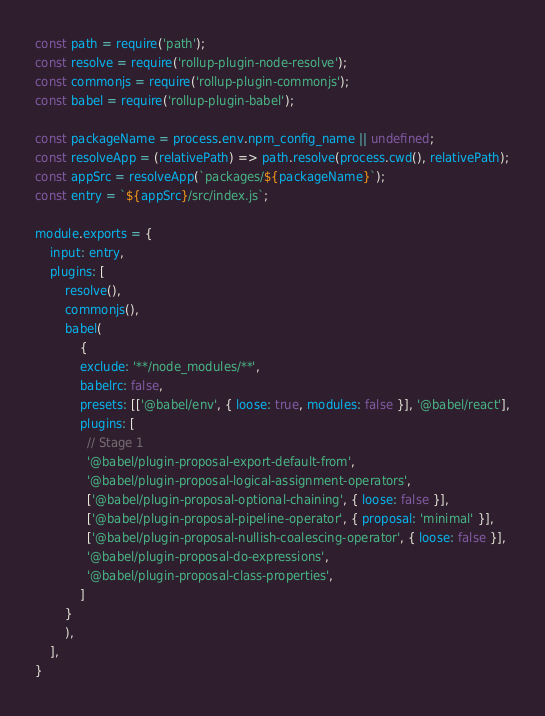Convert code to text. <code><loc_0><loc_0><loc_500><loc_500><_JavaScript_>const path = require('path');
const resolve = require('rollup-plugin-node-resolve');
const commonjs = require('rollup-plugin-commonjs');
const babel = require('rollup-plugin-babel');

const packageName = process.env.npm_config_name || undefined;
const resolveApp = (relativePath) => path.resolve(process.cwd(), relativePath);
const appSrc = resolveApp(`packages/${packageName}`);
const entry = `${appSrc}/src/index.js`;

module.exports = {
    input: entry,
    plugins: [
        resolve(),
        commonjs(),
        babel(
            {
            exclude: '**/node_modules/**',
            babelrc: false,
            presets: [['@babel/env', { loose: true, modules: false }], '@babel/react'],
            plugins: [
              // Stage 1
              '@babel/plugin-proposal-export-default-from',
              '@babel/plugin-proposal-logical-assignment-operators',
              ['@babel/plugin-proposal-optional-chaining', { loose: false }],
              ['@babel/plugin-proposal-pipeline-operator', { proposal: 'minimal' }],
              ['@babel/plugin-proposal-nullish-coalescing-operator', { loose: false }],
              '@babel/plugin-proposal-do-expressions',
              '@babel/plugin-proposal-class-properties',
            ]
        }
        ),
    ],
}</code> 